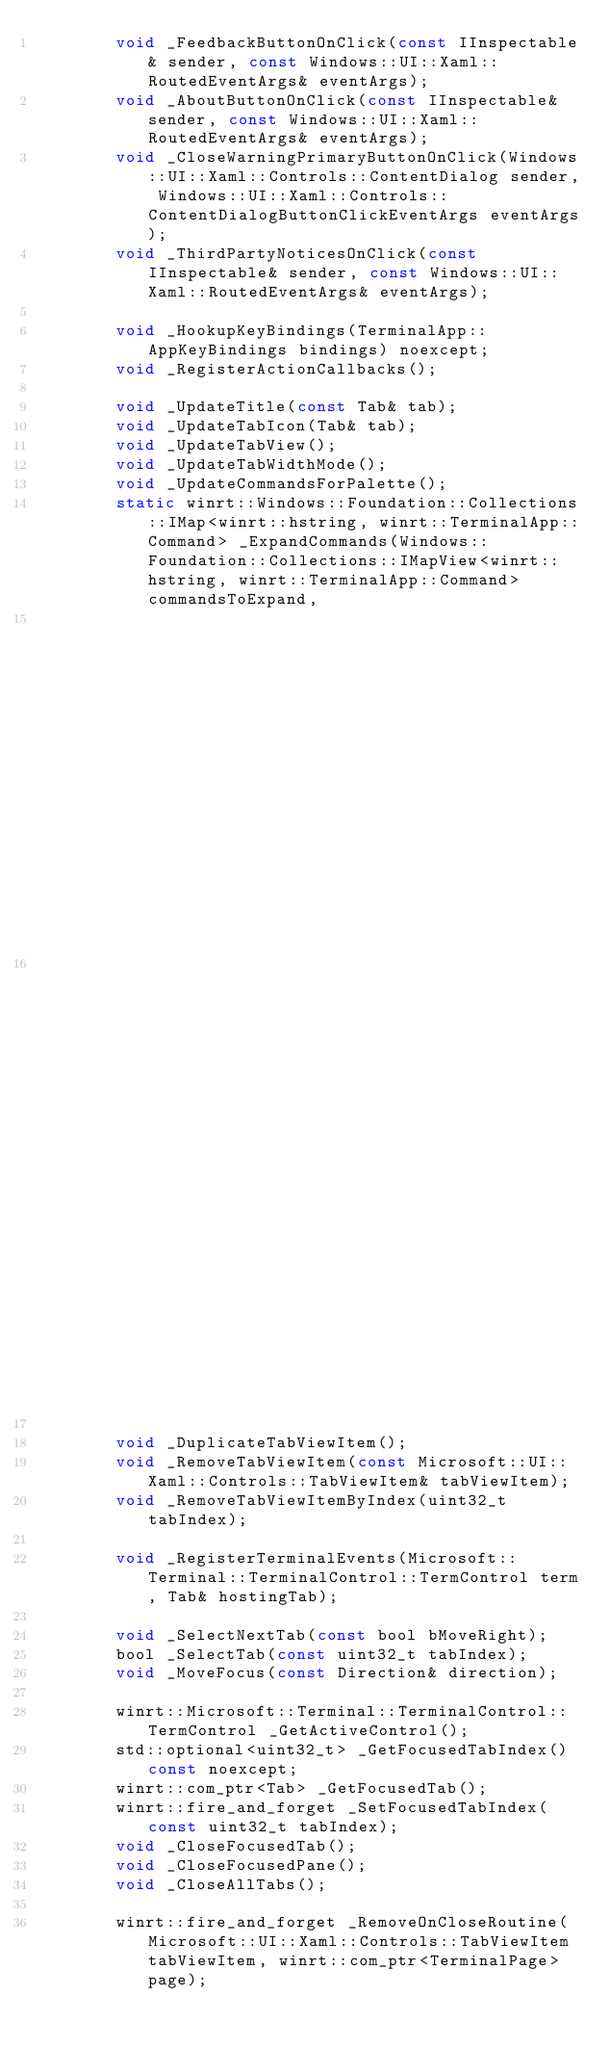Convert code to text. <code><loc_0><loc_0><loc_500><loc_500><_C_>        void _FeedbackButtonOnClick(const IInspectable& sender, const Windows::UI::Xaml::RoutedEventArgs& eventArgs);
        void _AboutButtonOnClick(const IInspectable& sender, const Windows::UI::Xaml::RoutedEventArgs& eventArgs);
        void _CloseWarningPrimaryButtonOnClick(Windows::UI::Xaml::Controls::ContentDialog sender, Windows::UI::Xaml::Controls::ContentDialogButtonClickEventArgs eventArgs);
        void _ThirdPartyNoticesOnClick(const IInspectable& sender, const Windows::UI::Xaml::RoutedEventArgs& eventArgs);

        void _HookupKeyBindings(TerminalApp::AppKeyBindings bindings) noexcept;
        void _RegisterActionCallbacks();

        void _UpdateTitle(const Tab& tab);
        void _UpdateTabIcon(Tab& tab);
        void _UpdateTabView();
        void _UpdateTabWidthMode();
        void _UpdateCommandsForPalette();
        static winrt::Windows::Foundation::Collections::IMap<winrt::hstring, winrt::TerminalApp::Command> _ExpandCommands(Windows::Foundation::Collections::IMapView<winrt::hstring, winrt::TerminalApp::Command> commandsToExpand,
                                                                                                                          Windows::Foundation::Collections::IVectorView<winrt::TerminalApp::Profile> profiles,
                                                                                                                          Windows::Foundation::Collections::IMapView<winrt::hstring, winrt::TerminalApp::ColorScheme> schemes);

        void _DuplicateTabViewItem();
        void _RemoveTabViewItem(const Microsoft::UI::Xaml::Controls::TabViewItem& tabViewItem);
        void _RemoveTabViewItemByIndex(uint32_t tabIndex);

        void _RegisterTerminalEvents(Microsoft::Terminal::TerminalControl::TermControl term, Tab& hostingTab);

        void _SelectNextTab(const bool bMoveRight);
        bool _SelectTab(const uint32_t tabIndex);
        void _MoveFocus(const Direction& direction);

        winrt::Microsoft::Terminal::TerminalControl::TermControl _GetActiveControl();
        std::optional<uint32_t> _GetFocusedTabIndex() const noexcept;
        winrt::com_ptr<Tab> _GetFocusedTab();
        winrt::fire_and_forget _SetFocusedTabIndex(const uint32_t tabIndex);
        void _CloseFocusedTab();
        void _CloseFocusedPane();
        void _CloseAllTabs();

        winrt::fire_and_forget _RemoveOnCloseRoutine(Microsoft::UI::Xaml::Controls::TabViewItem tabViewItem, winrt::com_ptr<TerminalPage> page);
</code> 